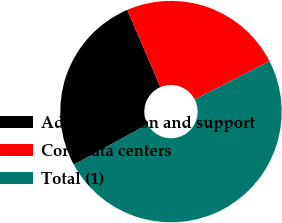Convert chart. <chart><loc_0><loc_0><loc_500><loc_500><pie_chart><fcel>Administration and support<fcel>Core data centers<fcel>Total (1)<nl><fcel>26.51%<fcel>23.95%<fcel>49.55%<nl></chart> 